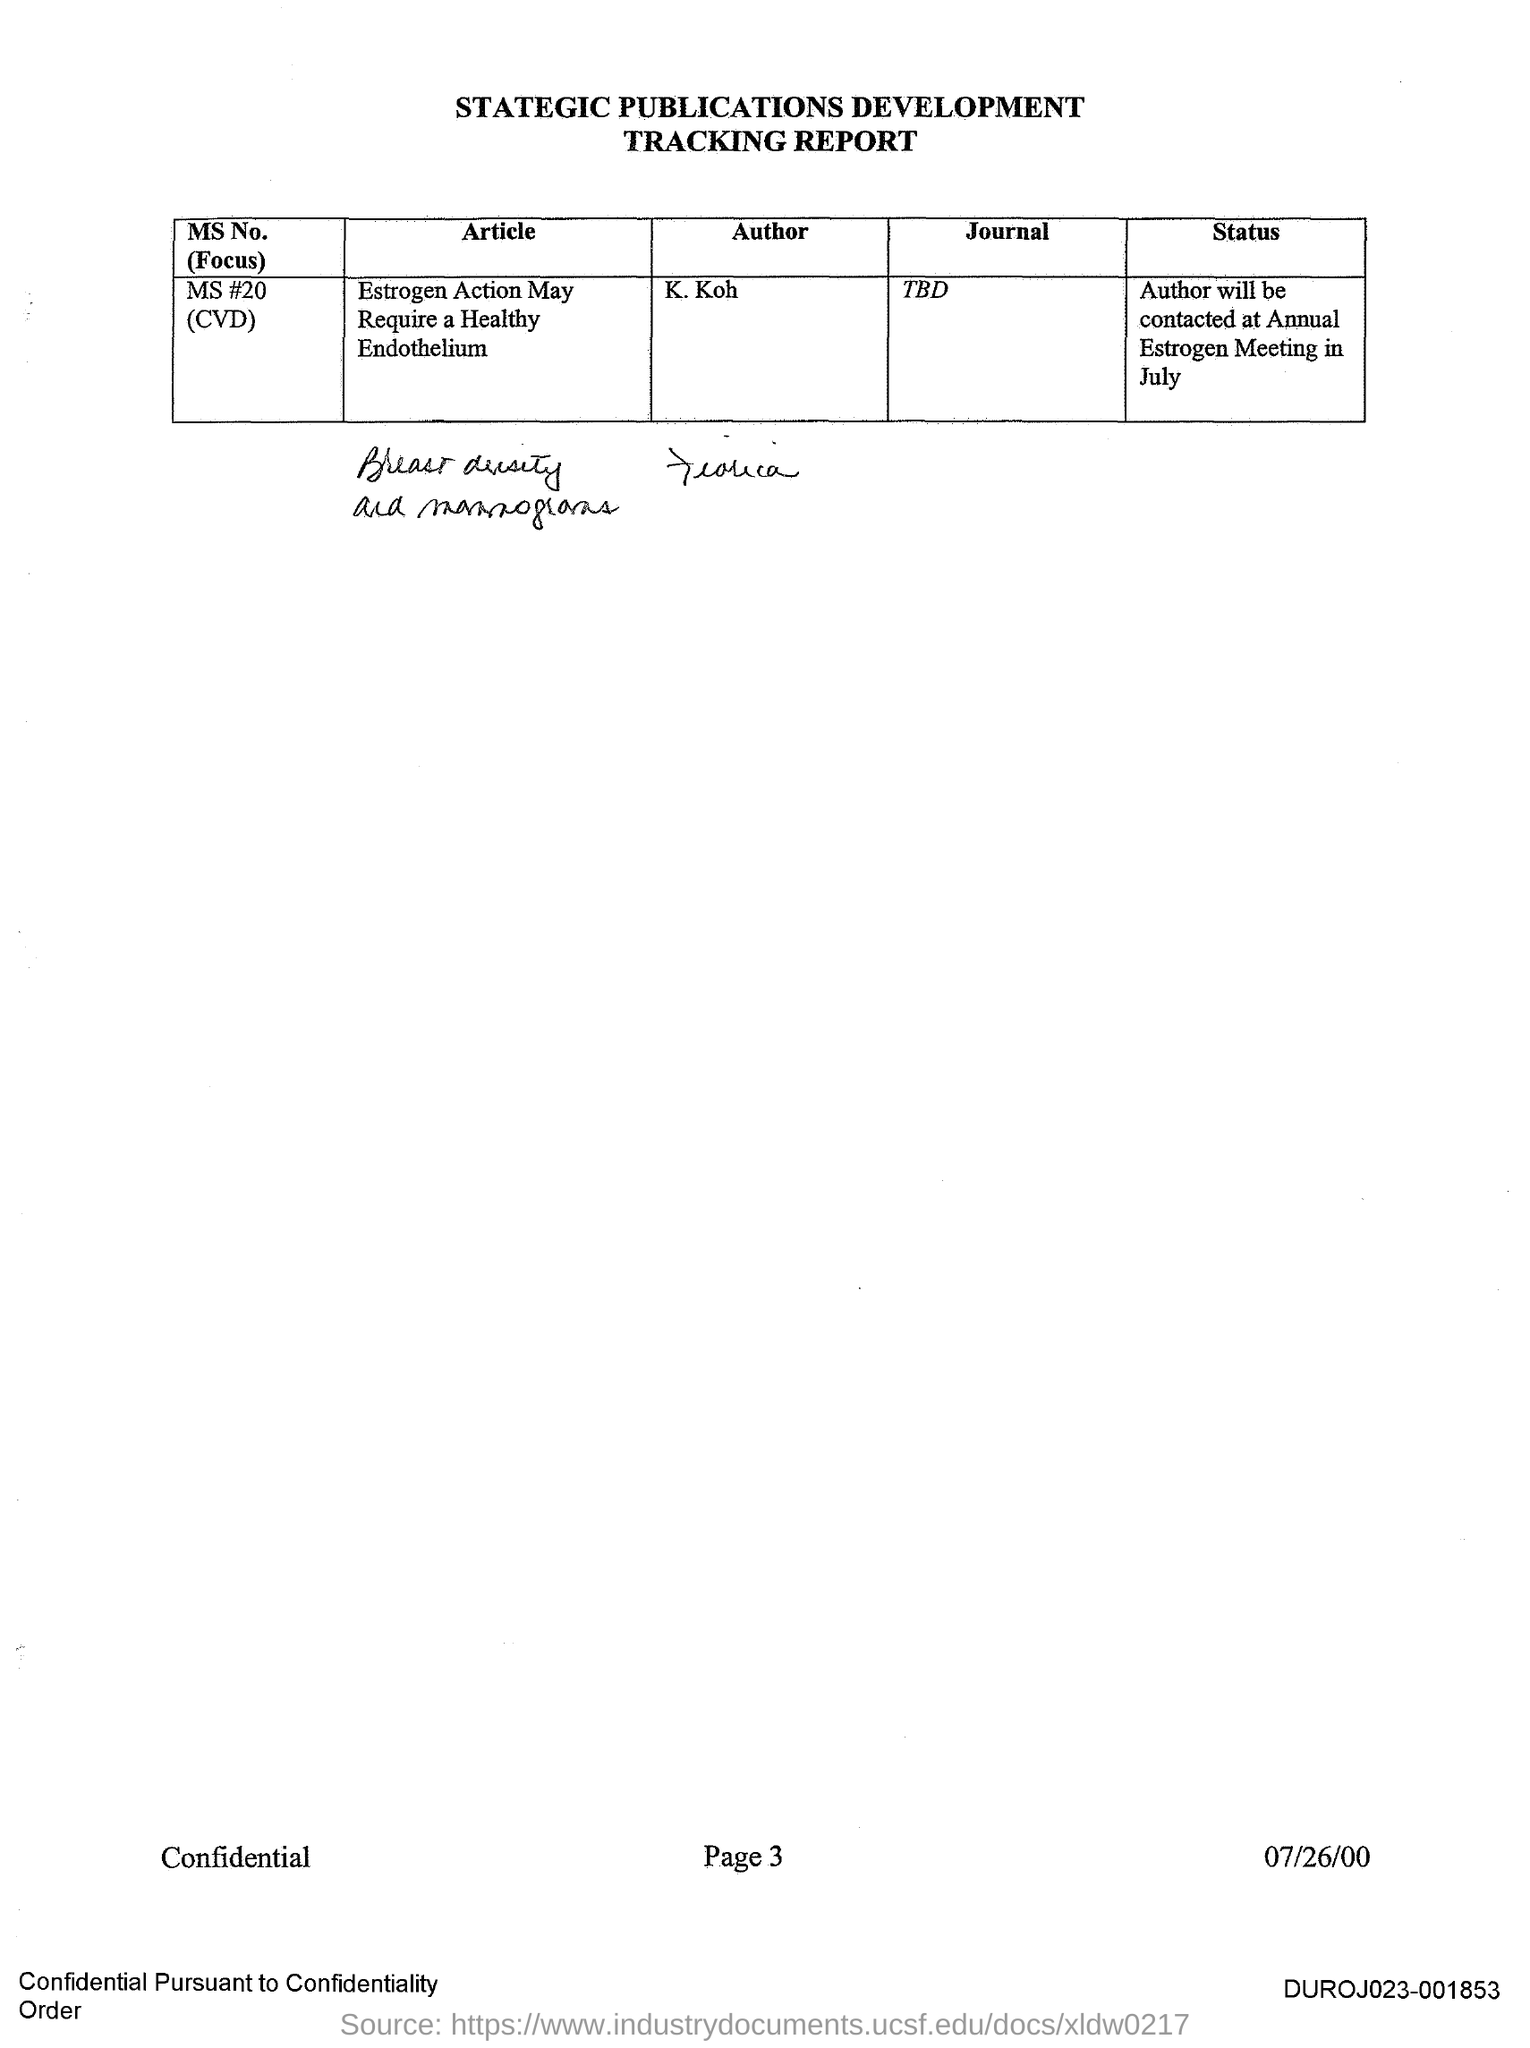Who is the Author for MS No. #20 (CVD)?
Offer a terse response. K. Koh. What is the Page?
Provide a short and direct response. 3. 